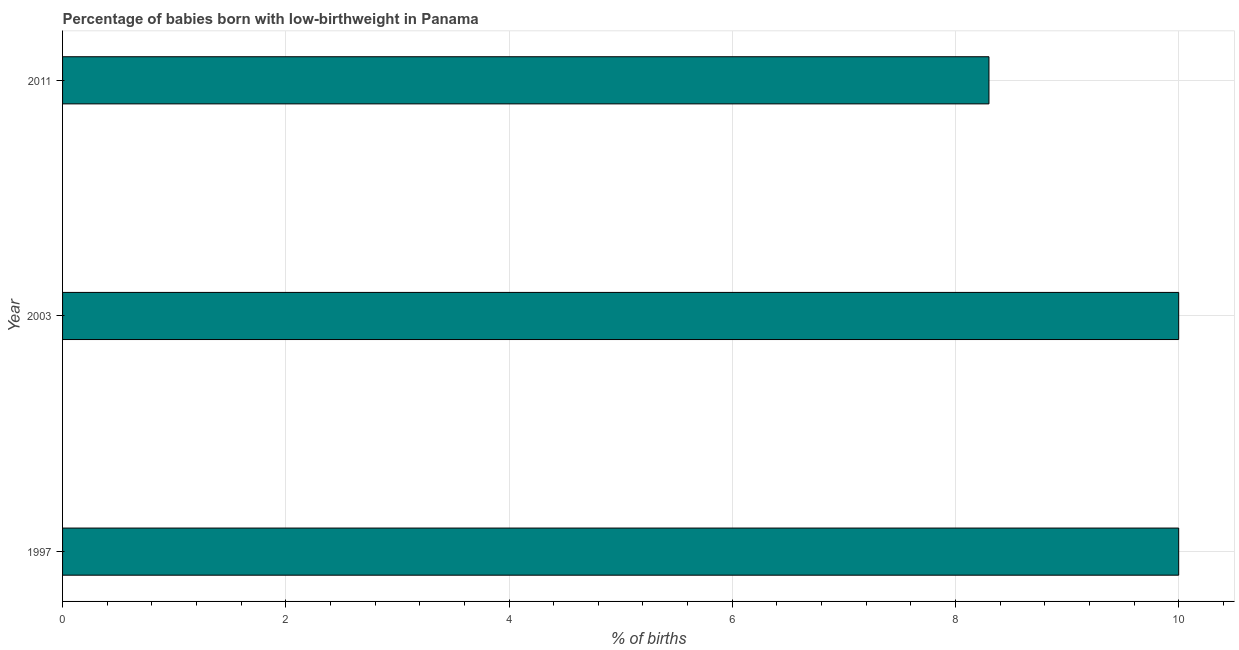Does the graph contain grids?
Provide a short and direct response. Yes. What is the title of the graph?
Your answer should be compact. Percentage of babies born with low-birthweight in Panama. What is the label or title of the X-axis?
Offer a very short reply. % of births. What is the percentage of babies who were born with low-birthweight in 1997?
Make the answer very short. 10. Across all years, what is the maximum percentage of babies who were born with low-birthweight?
Provide a short and direct response. 10. Across all years, what is the minimum percentage of babies who were born with low-birthweight?
Your response must be concise. 8.3. In which year was the percentage of babies who were born with low-birthweight maximum?
Your answer should be very brief. 1997. What is the sum of the percentage of babies who were born with low-birthweight?
Make the answer very short. 28.3. What is the average percentage of babies who were born with low-birthweight per year?
Your answer should be compact. 9.43. What is the ratio of the percentage of babies who were born with low-birthweight in 1997 to that in 2011?
Your answer should be very brief. 1.21. Is the percentage of babies who were born with low-birthweight in 1997 less than that in 2011?
Your response must be concise. No. Is the difference between the percentage of babies who were born with low-birthweight in 2003 and 2011 greater than the difference between any two years?
Give a very brief answer. Yes. What is the difference between the highest and the second highest percentage of babies who were born with low-birthweight?
Your response must be concise. 0. Is the sum of the percentage of babies who were born with low-birthweight in 1997 and 2011 greater than the maximum percentage of babies who were born with low-birthweight across all years?
Your answer should be very brief. Yes. How many bars are there?
Provide a succinct answer. 3. What is the difference between two consecutive major ticks on the X-axis?
Ensure brevity in your answer.  2. What is the difference between the % of births in 1997 and 2003?
Keep it short and to the point. 0. What is the ratio of the % of births in 1997 to that in 2003?
Ensure brevity in your answer.  1. What is the ratio of the % of births in 1997 to that in 2011?
Ensure brevity in your answer.  1.21. What is the ratio of the % of births in 2003 to that in 2011?
Your answer should be very brief. 1.21. 